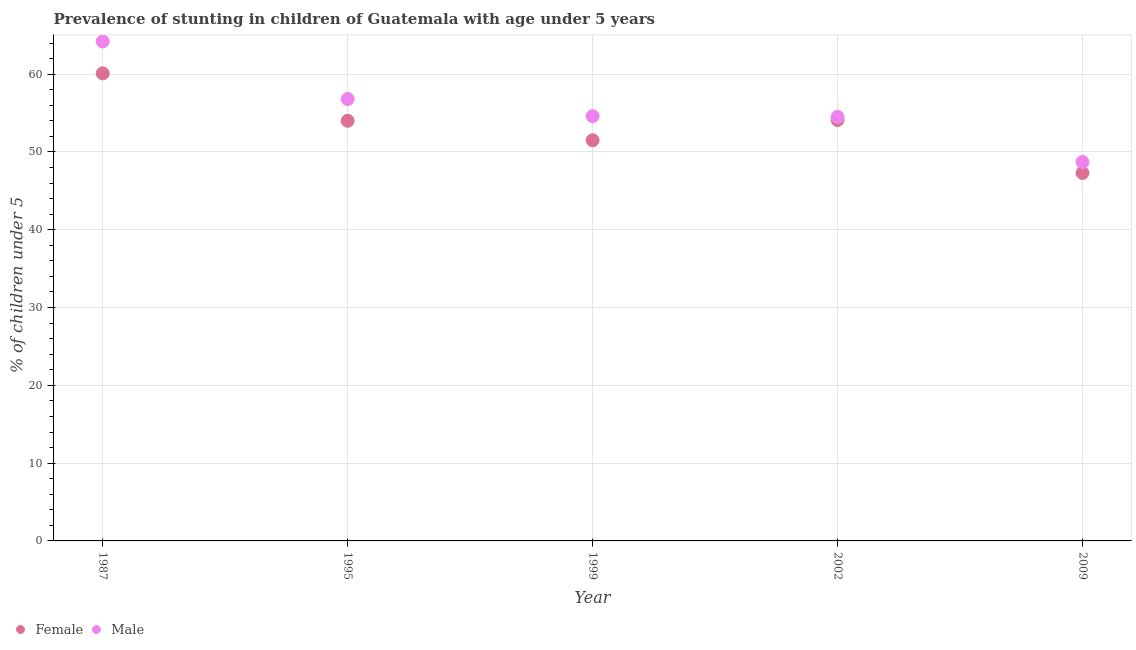How many different coloured dotlines are there?
Your answer should be compact. 2. What is the percentage of stunted female children in 2009?
Give a very brief answer. 47.3. Across all years, what is the maximum percentage of stunted male children?
Keep it short and to the point. 64.2. Across all years, what is the minimum percentage of stunted male children?
Offer a very short reply. 48.7. In which year was the percentage of stunted female children maximum?
Offer a very short reply. 1987. What is the total percentage of stunted female children in the graph?
Your response must be concise. 267. What is the difference between the percentage of stunted female children in 1995 and that in 1999?
Your response must be concise. 2.5. What is the difference between the percentage of stunted male children in 2009 and the percentage of stunted female children in 1995?
Provide a succinct answer. -5.3. What is the average percentage of stunted male children per year?
Provide a short and direct response. 55.76. In the year 2009, what is the difference between the percentage of stunted male children and percentage of stunted female children?
Provide a succinct answer. 1.4. What is the ratio of the percentage of stunted female children in 1995 to that in 1999?
Make the answer very short. 1.05. Is the percentage of stunted female children in 1995 less than that in 2002?
Your answer should be compact. Yes. Is the difference between the percentage of stunted female children in 1987 and 1999 greater than the difference between the percentage of stunted male children in 1987 and 1999?
Provide a succinct answer. No. What is the difference between the highest and the second highest percentage of stunted female children?
Make the answer very short. 6. What is the difference between the highest and the lowest percentage of stunted female children?
Your answer should be compact. 12.8. How many years are there in the graph?
Make the answer very short. 5. What is the difference between two consecutive major ticks on the Y-axis?
Your response must be concise. 10. Are the values on the major ticks of Y-axis written in scientific E-notation?
Provide a short and direct response. No. Does the graph contain any zero values?
Your answer should be compact. No. Does the graph contain grids?
Ensure brevity in your answer.  Yes. Where does the legend appear in the graph?
Offer a terse response. Bottom left. What is the title of the graph?
Your answer should be compact. Prevalence of stunting in children of Guatemala with age under 5 years. What is the label or title of the X-axis?
Ensure brevity in your answer.  Year. What is the label or title of the Y-axis?
Your answer should be compact.  % of children under 5. What is the  % of children under 5 of Female in 1987?
Your answer should be compact. 60.1. What is the  % of children under 5 of Male in 1987?
Make the answer very short. 64.2. What is the  % of children under 5 in Male in 1995?
Your response must be concise. 56.8. What is the  % of children under 5 of Female in 1999?
Keep it short and to the point. 51.5. What is the  % of children under 5 of Male in 1999?
Keep it short and to the point. 54.6. What is the  % of children under 5 in Female in 2002?
Give a very brief answer. 54.1. What is the  % of children under 5 of Male in 2002?
Your answer should be very brief. 54.5. What is the  % of children under 5 of Female in 2009?
Offer a terse response. 47.3. What is the  % of children under 5 in Male in 2009?
Ensure brevity in your answer.  48.7. Across all years, what is the maximum  % of children under 5 in Female?
Provide a succinct answer. 60.1. Across all years, what is the maximum  % of children under 5 of Male?
Your answer should be very brief. 64.2. Across all years, what is the minimum  % of children under 5 of Female?
Offer a terse response. 47.3. Across all years, what is the minimum  % of children under 5 of Male?
Offer a terse response. 48.7. What is the total  % of children under 5 of Female in the graph?
Your answer should be very brief. 267. What is the total  % of children under 5 of Male in the graph?
Your answer should be compact. 278.8. What is the difference between the  % of children under 5 of Female in 1987 and that in 1999?
Make the answer very short. 8.6. What is the difference between the  % of children under 5 of Male in 1987 and that in 1999?
Offer a very short reply. 9.6. What is the difference between the  % of children under 5 of Female in 1995 and that in 1999?
Make the answer very short. 2.5. What is the difference between the  % of children under 5 in Male in 1995 and that in 2002?
Make the answer very short. 2.3. What is the difference between the  % of children under 5 in Female in 1999 and that in 2002?
Make the answer very short. -2.6. What is the difference between the  % of children under 5 in Male in 1999 and that in 2009?
Offer a terse response. 5.9. What is the difference between the  % of children under 5 in Female in 1987 and the  % of children under 5 in Male in 1995?
Give a very brief answer. 3.3. What is the difference between the  % of children under 5 of Female in 1987 and the  % of children under 5 of Male in 2002?
Provide a short and direct response. 5.6. What is the difference between the  % of children under 5 of Female in 1995 and the  % of children under 5 of Male in 1999?
Provide a short and direct response. -0.6. What is the difference between the  % of children under 5 of Female in 1995 and the  % of children under 5 of Male in 2002?
Your answer should be compact. -0.5. What is the difference between the  % of children under 5 in Female in 1999 and the  % of children under 5 in Male in 2002?
Provide a short and direct response. -3. What is the difference between the  % of children under 5 of Female in 1999 and the  % of children under 5 of Male in 2009?
Keep it short and to the point. 2.8. What is the average  % of children under 5 in Female per year?
Your answer should be very brief. 53.4. What is the average  % of children under 5 in Male per year?
Offer a very short reply. 55.76. In the year 1995, what is the difference between the  % of children under 5 of Female and  % of children under 5 of Male?
Provide a succinct answer. -2.8. In the year 2002, what is the difference between the  % of children under 5 of Female and  % of children under 5 of Male?
Provide a short and direct response. -0.4. In the year 2009, what is the difference between the  % of children under 5 of Female and  % of children under 5 of Male?
Provide a short and direct response. -1.4. What is the ratio of the  % of children under 5 in Female in 1987 to that in 1995?
Your response must be concise. 1.11. What is the ratio of the  % of children under 5 in Male in 1987 to that in 1995?
Offer a terse response. 1.13. What is the ratio of the  % of children under 5 of Female in 1987 to that in 1999?
Your response must be concise. 1.17. What is the ratio of the  % of children under 5 in Male in 1987 to that in 1999?
Make the answer very short. 1.18. What is the ratio of the  % of children under 5 in Female in 1987 to that in 2002?
Provide a succinct answer. 1.11. What is the ratio of the  % of children under 5 in Male in 1987 to that in 2002?
Your answer should be compact. 1.18. What is the ratio of the  % of children under 5 in Female in 1987 to that in 2009?
Give a very brief answer. 1.27. What is the ratio of the  % of children under 5 of Male in 1987 to that in 2009?
Make the answer very short. 1.32. What is the ratio of the  % of children under 5 of Female in 1995 to that in 1999?
Ensure brevity in your answer.  1.05. What is the ratio of the  % of children under 5 in Male in 1995 to that in 1999?
Provide a short and direct response. 1.04. What is the ratio of the  % of children under 5 in Female in 1995 to that in 2002?
Provide a short and direct response. 1. What is the ratio of the  % of children under 5 of Male in 1995 to that in 2002?
Provide a short and direct response. 1.04. What is the ratio of the  % of children under 5 in Female in 1995 to that in 2009?
Make the answer very short. 1.14. What is the ratio of the  % of children under 5 in Male in 1995 to that in 2009?
Offer a terse response. 1.17. What is the ratio of the  % of children under 5 in Female in 1999 to that in 2002?
Provide a short and direct response. 0.95. What is the ratio of the  % of children under 5 in Female in 1999 to that in 2009?
Offer a very short reply. 1.09. What is the ratio of the  % of children under 5 of Male in 1999 to that in 2009?
Your answer should be compact. 1.12. What is the ratio of the  % of children under 5 of Female in 2002 to that in 2009?
Offer a very short reply. 1.14. What is the ratio of the  % of children under 5 of Male in 2002 to that in 2009?
Provide a short and direct response. 1.12. What is the difference between the highest and the lowest  % of children under 5 of Male?
Make the answer very short. 15.5. 